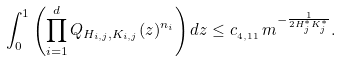Convert formula to latex. <formula><loc_0><loc_0><loc_500><loc_500>\int _ { 0 } ^ { 1 } \left ( \prod _ { i = 1 } ^ { d } Q _ { H _ { i , j } , K _ { i , j } } ( z ) ^ { n _ { i } } \right ) d z \leq c _ { _ { 4 , 1 1 } } \, m ^ { - \frac { 1 } { 2 H _ { j } ^ { \ast } K _ { j } ^ { \ast } } } .</formula> 